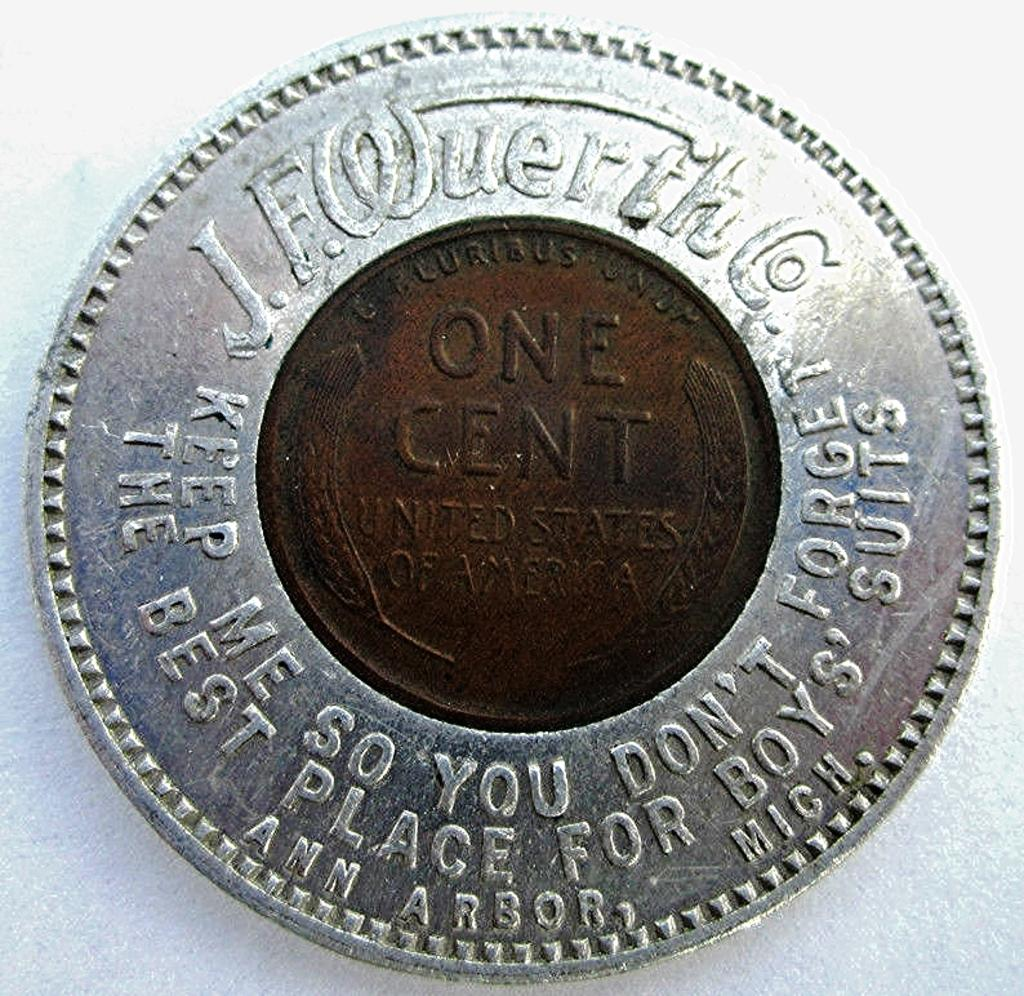<image>
Share a concise interpretation of the image provided. The United States of America produces copper one cent penny's 